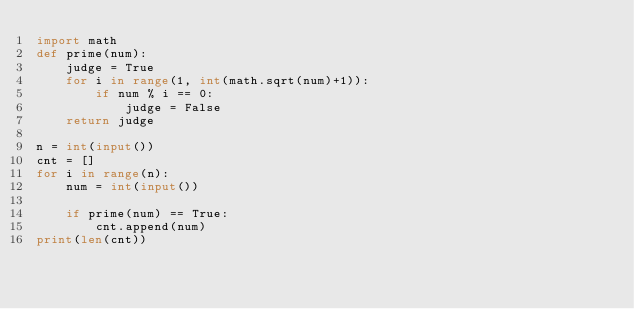<code> <loc_0><loc_0><loc_500><loc_500><_Python_>import math
def prime(num):
    judge = True
    for i in range(1, int(math.sqrt(num)+1)):
        if num % i == 0:
            judge = False
    return judge
    
n = int(input())
cnt = []
for i in range(n):
    num = int(input())
    
    if prime(num) == True:
        cnt.append(num)
print(len(cnt))
</code> 